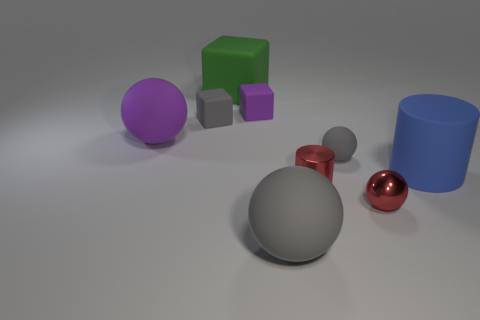How do the sizes of the purple sphere and the green cube compare? The purple sphere is larger than the green cube. The sphere's diameter surpasses the cube's height and width, making the sphere stand out as one of the larger objects in the image, second to the gray sphere. What might be the context or purpose of this arrangement of objects? This arrangement of objects appears to be a simple composition perhaps designed for a visual study or a test render. The different colors, shapes, and materials might be used to demonstrate lighting, shading, and texturing in a 3D modeling software. 